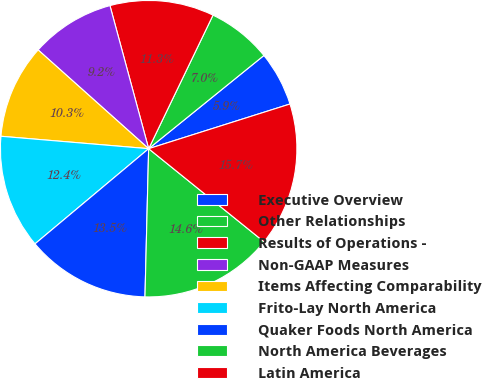Convert chart. <chart><loc_0><loc_0><loc_500><loc_500><pie_chart><fcel>Executive Overview<fcel>Other Relationships<fcel>Results of Operations -<fcel>Non-GAAP Measures<fcel>Items Affecting Comparability<fcel>Frito-Lay North America<fcel>Quaker Foods North America<fcel>North America Beverages<fcel>Latin America<nl><fcel>5.95%<fcel>7.03%<fcel>11.35%<fcel>9.19%<fcel>10.27%<fcel>12.43%<fcel>13.51%<fcel>14.59%<fcel>15.68%<nl></chart> 